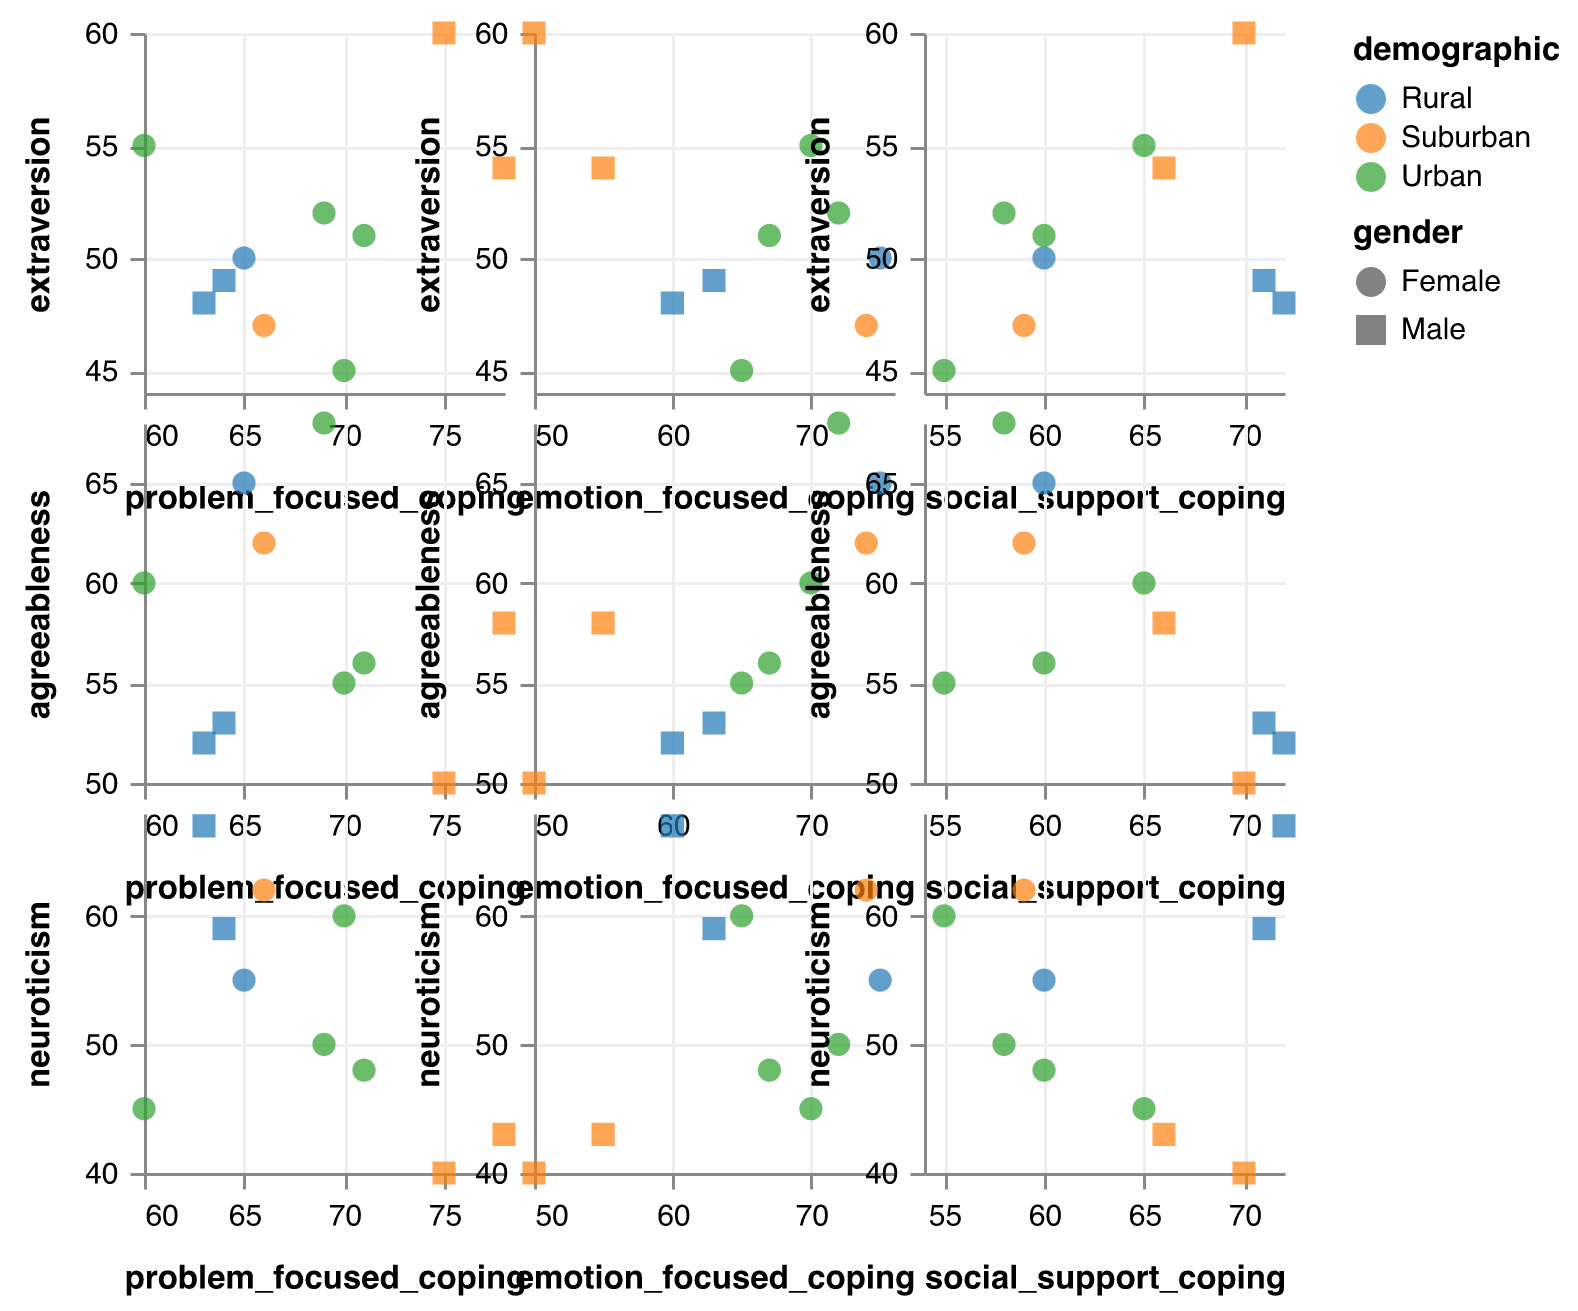What are the axis ranges for 'extraversion' and 'problem_focused_coping'? The axis range for 'extraversion' is determined by the lowest and highest values plotted on that axis, similarly for 'problem_focused_coping'. By observing the plotted points, we can estimate the ranges. 'Extraversion' ranges from approximately 45 to 60 and 'problem_focused_coping' ranges from about 60 to 78.
Answer: Extraversion: 45-60, Problem-focused coping: 60-78 How many data points are there for each demographic group? We need to count the number of data points (each represented by a different color) for each demographic group. Observing the colors representing 'Urban,' 'Suburban,' and 'Rural,' we see the counts are: Urban has 4 points, Suburban has 3 points, and Rural has 3 points.
Answer: Urban: 4, Suburban: 3, Rural: 3 Which demographic group has the highest 'neuroticism' score and what is the score? We need to look for the highest 'neuroticism' score on the y-axis and check the corresponding color representing the demographic group. The highest 'neuroticism' score is 67, and it belongs to the 'Rural' demographic group.
Answer: Rural, 67 Is there any visible correlation between 'agreeableness' and 'emotion_focused_coping'? To answer this, observe the scatter plot of 'agreeableness' vs 'emotion_focused_coping'. Look at the overall pattern of points. No clear upward or downward trend is visible, indicating no strong correlation.
Answer: No visible correlation For the 'Suburban' demographic group, what is the average 'problem_focused_coping' score? Identify the data points colored for 'Suburban' and their corresponding 'problem_focused_coping' scores: 75, 78, 66. Sum these values and divide by the number of points. (75 + 78 + 66) / 3 = 219 / 3 = 73
Answer: 73 Which gender has a higher average score in 'social_support_coping'? Separate the data points by gender and calculate the average score for 'social_support_coping'. For 'Female': (55 + 60 + 65 + 58 + 59 + 60) / 6 = 357 / 6 = 59.5 and for 'Male': (70 + 72 + 66 + 71) / 4 = 279 / 4 = 69.75.
Answer: Male Which pair of traits, 'extraversion' and 'problem_focused_coping', or 'neuroticism' and 'social_support_coping', has a stronger correlation visually? Observe the scatter plots for both pairs. For 'extraversion' and 'problem_focused_coping', there is a notable upward trend. For 'neuroticism' and 'social_support_coping', the points are more scattered. Therefore, 'extraversion' and 'problem_focused_coping' have a stronger correlation.
Answer: Extraversion and problem_focused_coping What is the relationship between 'age' and 'social_support_coping' for the 'Urban' demographic? Filter for 'Urban' demographic points and observe if there is any trend between 'age' (from tooltips) and 'social_support_coping'. The tooltips indicate no clear age trend with 'social_support_coping' scores in the 'Urban' demographic group.
Answer: No clear relationship Is there any outlier in 'agreeableness' when compared to 'social_support_coping' for any demographic group? Look for points that stand apart far from others in the scatter plot of 'agreeableness' vs 'social_support_coping'. No individual points are significantly distant from others, suggesting there are no outliers.
Answer: No outliers 